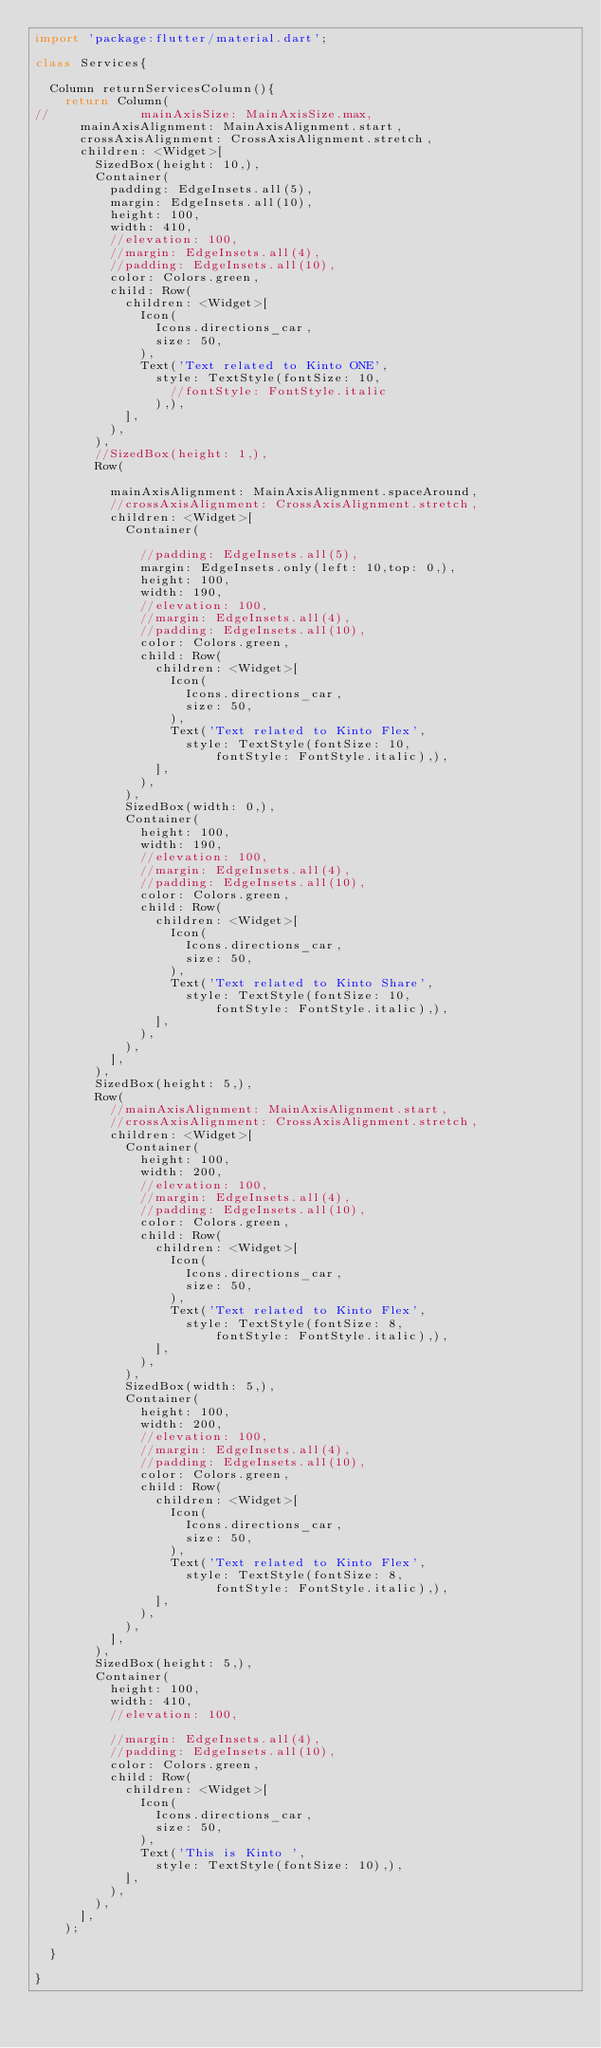<code> <loc_0><loc_0><loc_500><loc_500><_Dart_>import 'package:flutter/material.dart';

class Services{

  Column returnServicesColumn(){
    return Column(
//            mainAxisSize: MainAxisSize.max,
      mainAxisAlignment: MainAxisAlignment.start,
      crossAxisAlignment: CrossAxisAlignment.stretch,
      children: <Widget>[
        SizedBox(height: 10,),
        Container(
          padding: EdgeInsets.all(5),
          margin: EdgeInsets.all(10),
          height: 100,
          width: 410,
          //elevation: 100,
          //margin: EdgeInsets.all(4),
          //padding: EdgeInsets.all(10),
          color: Colors.green,
          child: Row(
            children: <Widget>[
              Icon(
                Icons.directions_car,
                size: 50,
              ),
              Text('Text related to Kinto ONE',
                style: TextStyle(fontSize: 10,
                  //fontStyle: FontStyle.italic
                ),),
            ],
          ),
        ),
        //SizedBox(height: 1,),
        Row(

          mainAxisAlignment: MainAxisAlignment.spaceAround,
          //crossAxisAlignment: CrossAxisAlignment.stretch,
          children: <Widget>[
            Container(

              //padding: EdgeInsets.all(5),
              margin: EdgeInsets.only(left: 10,top: 0,),
              height: 100,
              width: 190,
              //elevation: 100,
              //margin: EdgeInsets.all(4),
              //padding: EdgeInsets.all(10),
              color: Colors.green,
              child: Row(
                children: <Widget>[
                  Icon(
                    Icons.directions_car,
                    size: 50,
                  ),
                  Text('Text related to Kinto Flex',
                    style: TextStyle(fontSize: 10,
                        fontStyle: FontStyle.italic),),
                ],
              ),
            ),
            SizedBox(width: 0,),
            Container(
              height: 100,
              width: 190,
              //elevation: 100,
              //margin: EdgeInsets.all(4),
              //padding: EdgeInsets.all(10),
              color: Colors.green,
              child: Row(
                children: <Widget>[
                  Icon(
                    Icons.directions_car,
                    size: 50,
                  ),
                  Text('Text related to Kinto Share',
                    style: TextStyle(fontSize: 10,
                        fontStyle: FontStyle.italic),),
                ],
              ),
            ),
          ],
        ),
        SizedBox(height: 5,),
        Row(
          //mainAxisAlignment: MainAxisAlignment.start,
          //crossAxisAlignment: CrossAxisAlignment.stretch,
          children: <Widget>[
            Container(
              height: 100,
              width: 200,
              //elevation: 100,
              //margin: EdgeInsets.all(4),
              //padding: EdgeInsets.all(10),
              color: Colors.green,
              child: Row(
                children: <Widget>[
                  Icon(
                    Icons.directions_car,
                    size: 50,
                  ),
                  Text('Text related to Kinto Flex',
                    style: TextStyle(fontSize: 8,
                        fontStyle: FontStyle.italic),),
                ],
              ),
            ),
            SizedBox(width: 5,),
            Container(
              height: 100,
              width: 200,
              //elevation: 100,
              //margin: EdgeInsets.all(4),
              //padding: EdgeInsets.all(10),
              color: Colors.green,
              child: Row(
                children: <Widget>[
                  Icon(
                    Icons.directions_car,
                    size: 50,
                  ),
                  Text('Text related to Kinto Flex',
                    style: TextStyle(fontSize: 8,
                        fontStyle: FontStyle.italic),),
                ],
              ),
            ),
          ],
        ),
        SizedBox(height: 5,),
        Container(
          height: 100,
          width: 410,
          //elevation: 100,

          //margin: EdgeInsets.all(4),
          //padding: EdgeInsets.all(10),
          color: Colors.green,
          child: Row(
            children: <Widget>[
              Icon(
                Icons.directions_car,
                size: 50,
              ),
              Text('This is Kinto ',
                style: TextStyle(fontSize: 10),),
            ],
          ),
        ),
      ],
    );

  }

}</code> 